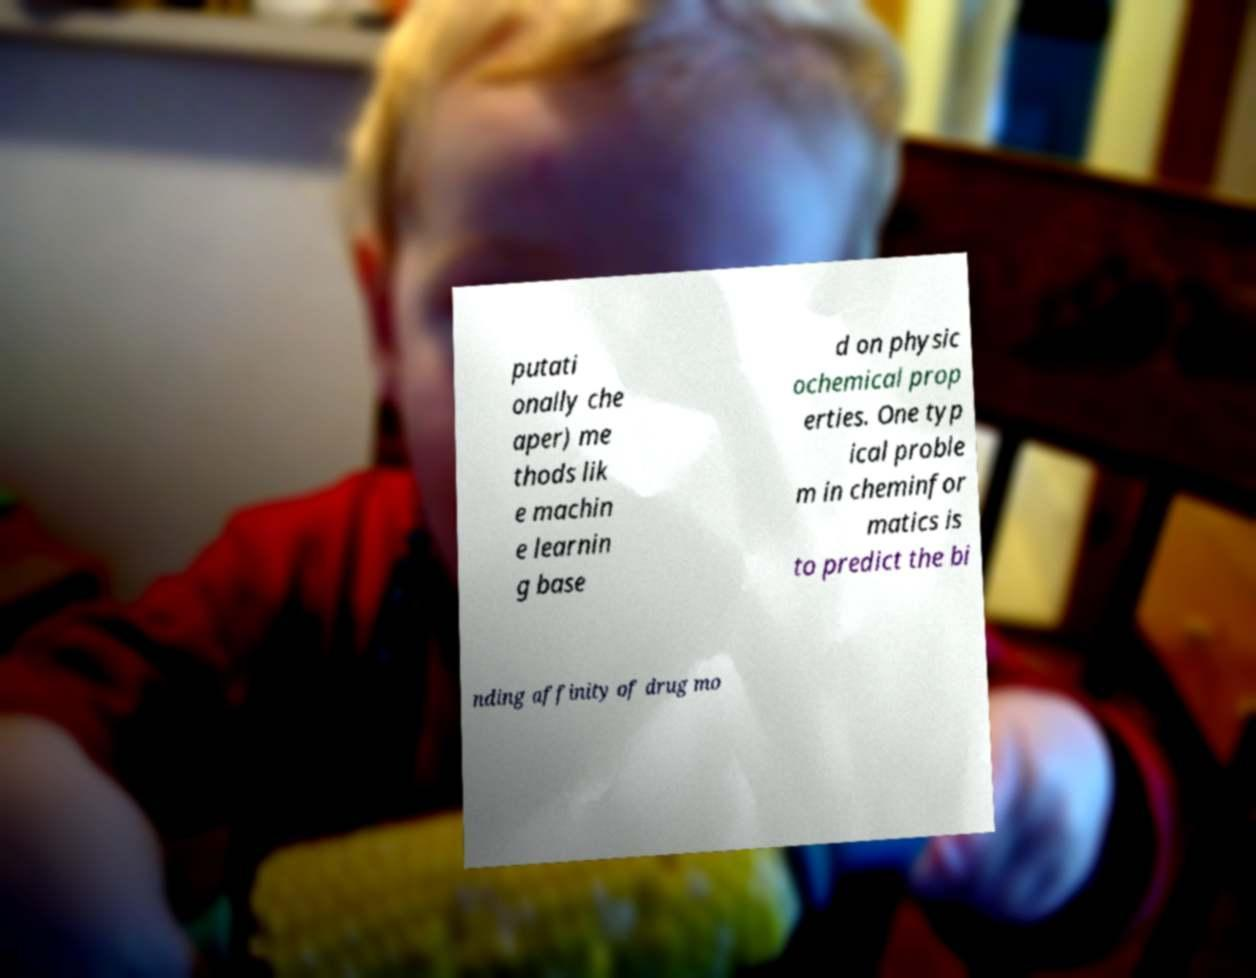Could you extract and type out the text from this image? putati onally che aper) me thods lik e machin e learnin g base d on physic ochemical prop erties. One typ ical proble m in cheminfor matics is to predict the bi nding affinity of drug mo 